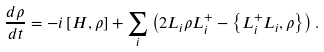<formula> <loc_0><loc_0><loc_500><loc_500>\frac { d \rho } { d t } = - i \left [ H , \rho \right ] + \sum _ { i } \left ( 2 L _ { i } \rho L ^ { + } _ { i } - \left \{ L ^ { + } _ { i } L _ { i } , \rho \right \} \right ) .</formula> 